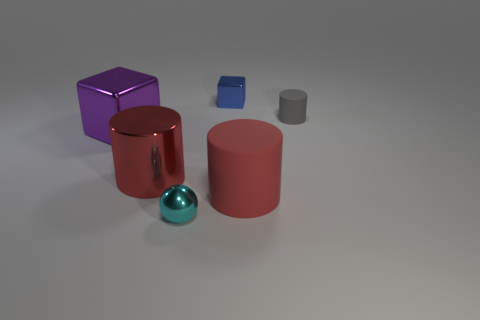Add 2 large metallic cubes. How many objects exist? 8 Subtract all blocks. How many objects are left? 4 Subtract all big brown matte cylinders. Subtract all rubber objects. How many objects are left? 4 Add 4 red rubber things. How many red rubber things are left? 5 Add 3 gray things. How many gray things exist? 4 Subtract 0 brown balls. How many objects are left? 6 